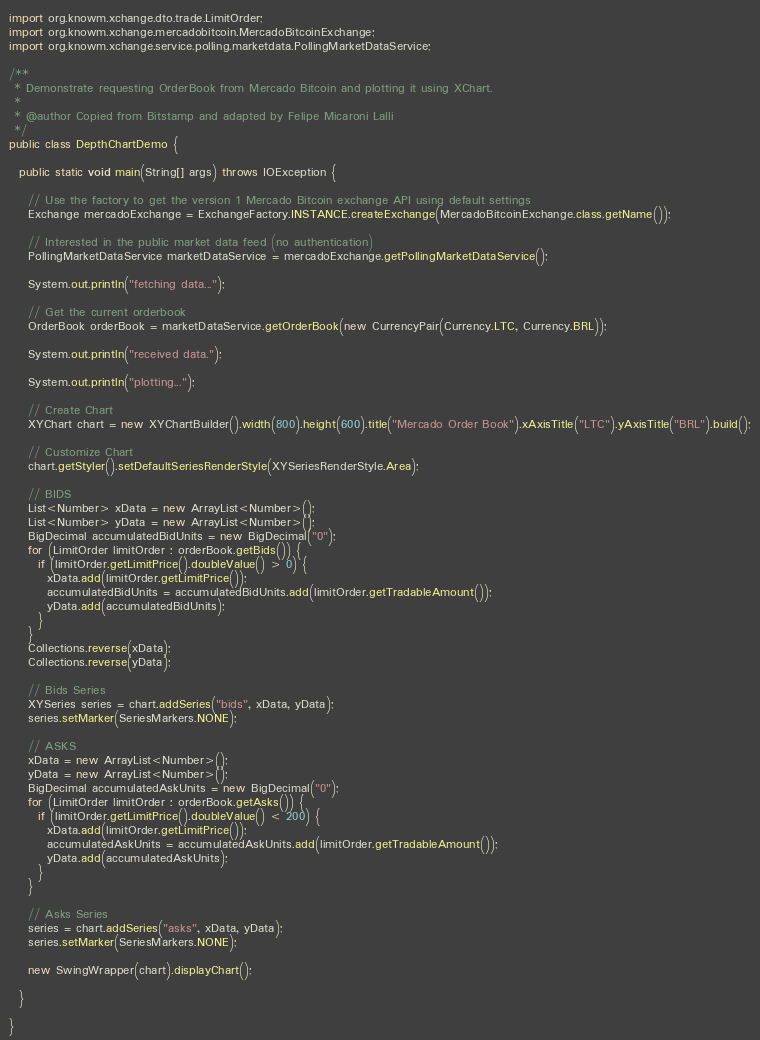Convert code to text. <code><loc_0><loc_0><loc_500><loc_500><_Java_>import org.knowm.xchange.dto.trade.LimitOrder;
import org.knowm.xchange.mercadobitcoin.MercadoBitcoinExchange;
import org.knowm.xchange.service.polling.marketdata.PollingMarketDataService;

/**
 * Demonstrate requesting OrderBook from Mercado Bitcoin and plotting it using XChart.
 *
 * @author Copied from Bitstamp and adapted by Felipe Micaroni Lalli
 */
public class DepthChartDemo {

  public static void main(String[] args) throws IOException {

    // Use the factory to get the version 1 Mercado Bitcoin exchange API using default settings
    Exchange mercadoExchange = ExchangeFactory.INSTANCE.createExchange(MercadoBitcoinExchange.class.getName());

    // Interested in the public market data feed (no authentication)
    PollingMarketDataService marketDataService = mercadoExchange.getPollingMarketDataService();

    System.out.println("fetching data...");

    // Get the current orderbook
    OrderBook orderBook = marketDataService.getOrderBook(new CurrencyPair(Currency.LTC, Currency.BRL));

    System.out.println("received data.");

    System.out.println("plotting...");

    // Create Chart
    XYChart chart = new XYChartBuilder().width(800).height(600).title("Mercado Order Book").xAxisTitle("LTC").yAxisTitle("BRL").build();

    // Customize Chart
    chart.getStyler().setDefaultSeriesRenderStyle(XYSeriesRenderStyle.Area);

    // BIDS
    List<Number> xData = new ArrayList<Number>();
    List<Number> yData = new ArrayList<Number>();
    BigDecimal accumulatedBidUnits = new BigDecimal("0");
    for (LimitOrder limitOrder : orderBook.getBids()) {
      if (limitOrder.getLimitPrice().doubleValue() > 0) {
        xData.add(limitOrder.getLimitPrice());
        accumulatedBidUnits = accumulatedBidUnits.add(limitOrder.getTradableAmount());
        yData.add(accumulatedBidUnits);
      }
    }
    Collections.reverse(xData);
    Collections.reverse(yData);

    // Bids Series
    XYSeries series = chart.addSeries("bids", xData, yData);
    series.setMarker(SeriesMarkers.NONE);

    // ASKS
    xData = new ArrayList<Number>();
    yData = new ArrayList<Number>();
    BigDecimal accumulatedAskUnits = new BigDecimal("0");
    for (LimitOrder limitOrder : orderBook.getAsks()) {
      if (limitOrder.getLimitPrice().doubleValue() < 200) {
        xData.add(limitOrder.getLimitPrice());
        accumulatedAskUnits = accumulatedAskUnits.add(limitOrder.getTradableAmount());
        yData.add(accumulatedAskUnits);
      }
    }

    // Asks Series
    series = chart.addSeries("asks", xData, yData);
    series.setMarker(SeriesMarkers.NONE);

    new SwingWrapper(chart).displayChart();

  }

}
</code> 